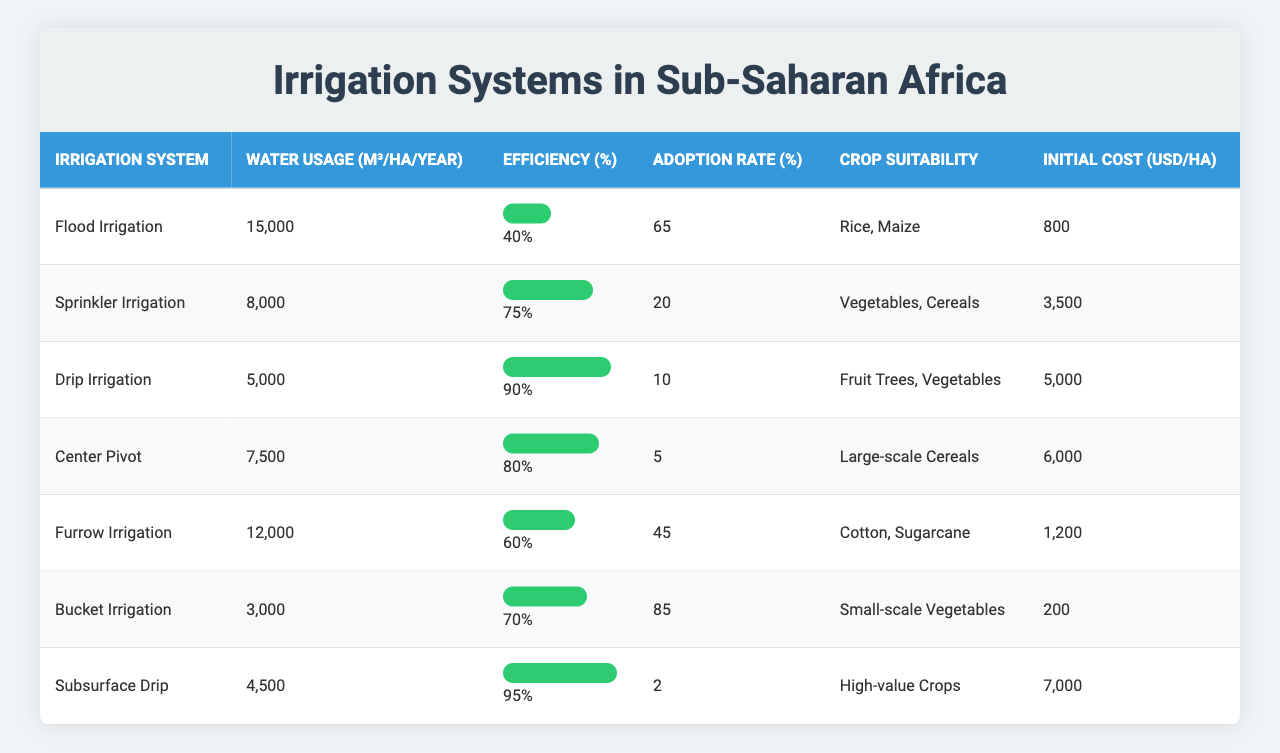What is the water usage for Flood Irrigation? The table lists the water usage for Flood Irrigation as 15,000 m³/ha/year.
Answer: 15,000 m³/ha/year Which irrigation system has the highest efficiency? The table shows that Subsurface Drip has an efficiency of 95%, which is the highest among all listed systems.
Answer: Subsurface Drip What is the total water usage for Drip and Sprinkler Irrigation combined? The water usage for Drip Irrigation is 5,000 m³/ha/year and for Sprinkler Irrigation, it is 8,000 m³/ha/year. Adding these gives 5,000 + 8,000 = 13,000 m³/ha/year.
Answer: 13,000 m³/ha/year Is the adoption rate for Center Pivot Irrigation above 10%? The table indicates that the adoption rate for Center Pivot is 5%, which is not above 10%.
Answer: No Which irrigation system is suitable for small-scale vegetables and has the lowest initial cost? Bucket Irrigation is suitable for small-scale vegetables and has the lowest initial cost at 200 USD/ha compared to the others.
Answer: Bucket Irrigation What is the average initial cost of the irrigation systems listed? The initial costs are 800, 3,500, 5,000, 6,000, 1,200, 200, and 7,000. Summing these gives 800 + 3,500 + 5,000 + 6,000 + 1,200 + 200 + 7,000 = 23,700. There are 7 systems, so the average is 23,700 / 7 = approximately 3,386 USD/ha.
Answer: Approximately 3,386 USD/ha Which irrigation system has a lower efficiency, Flood Irrigation or Furrow Irrigation? Flood Irrigation has an efficiency of 40% while Furrow Irrigation has 60%. Since 40% is lower than 60%, Flood Irrigation has the lower efficiency.
Answer: Flood Irrigation How much more water is used by Center Pivot than by Subsurface Drip irrigation? The water usage for Center Pivot is 7,500 m³/ha/year and for Subsurface Drip it is 4,500 m³/ha/year. The difference is 7,500 - 4,500 = 3,000 m³/ha/year.
Answer: 3,000 m³/ha/year Is Drip Irrigation suitable for high-value crops? The table states that Drip Irrigation is suitable for Fruit Trees and Vegetables, which are typically not categorized as high-value crops.
Answer: No What is the system with the highest adoption rate, and what is that rate? The table shows that Bucket Irrigation has the highest adoption rate at 85%.
Answer: Bucket Irrigation; 85% 